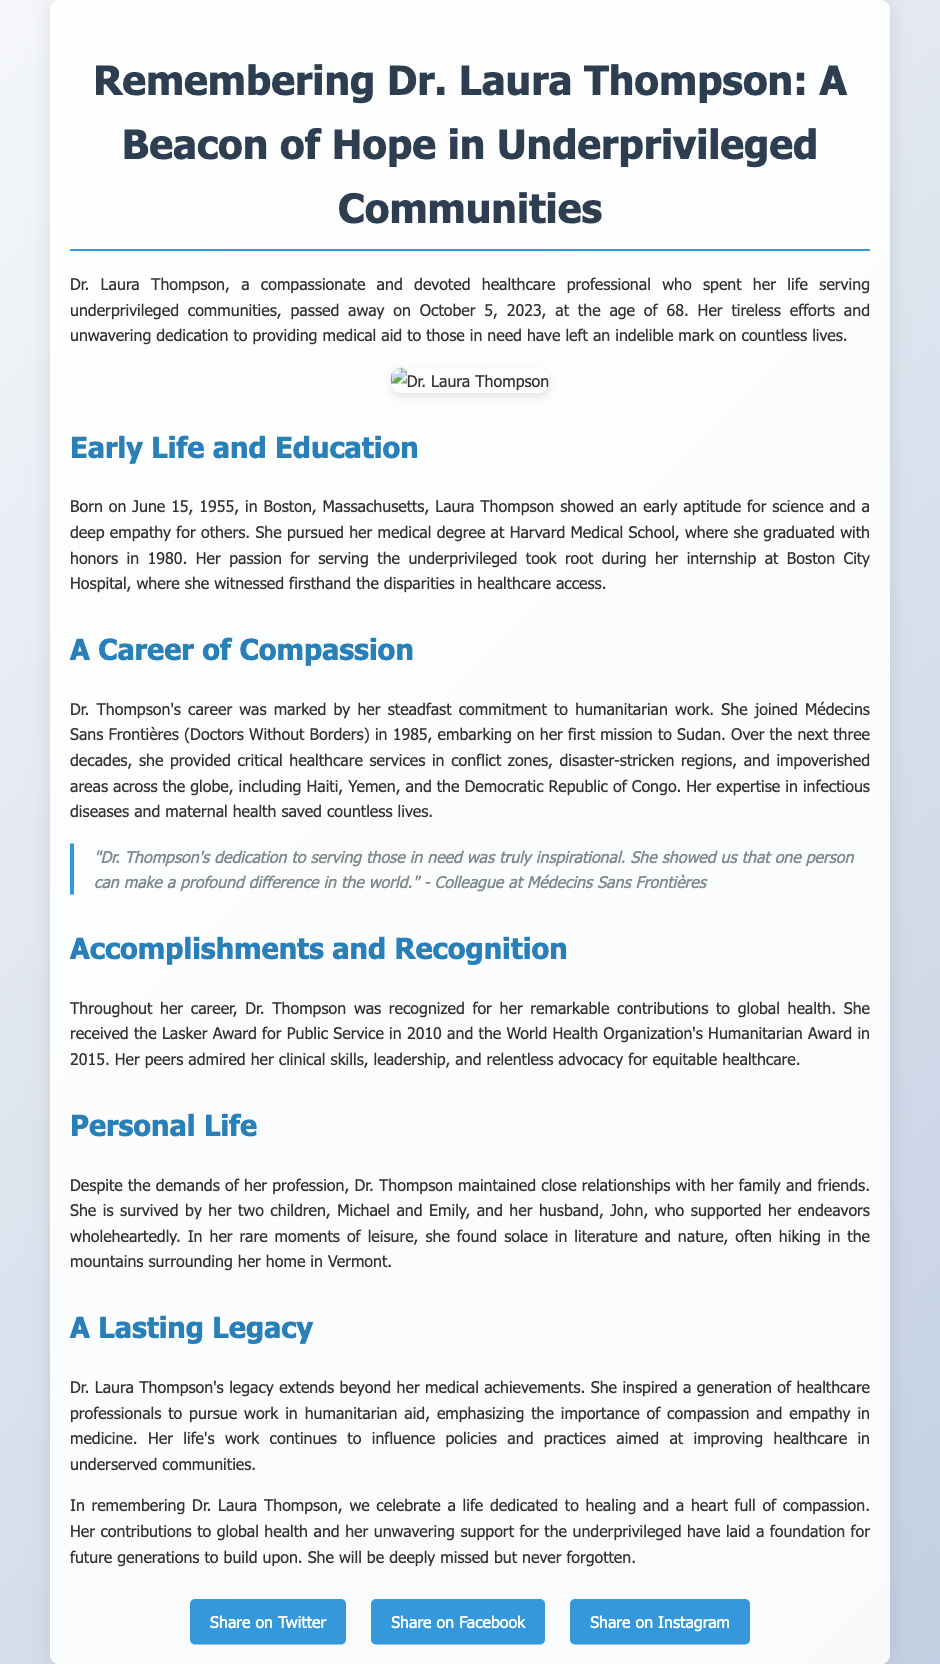What was Dr. Laura Thompson's profession? The document describes her as a healthcare professional who devoted her life to serving underprivileged communities.
Answer: healthcare professional When did Dr. Laura Thompson pass away? The obituary states that she passed away on October 5, 2023.
Answer: October 5, 2023 What award did Dr. Thompson receive in 2010? The document mentions that she received the Lasker Award for Public Service in 2010.
Answer: Lasker Award for Public Service In which country did Dr. Thompson embark on her first mission with Médecins Sans Frontières? The document states that her first mission was to Sudan.
Answer: Sudan What year was Dr. Laura Thompson born? The document states she was born on June 15, 1955.
Answer: 1955 How many children did Dr. Thompson have? The personal life section notes that she is survived by her two children.
Answer: two What major theme does Dr. Thompson’s legacy represent in global health? The document emphasizes her legacy of inspiring healthcare professionals to pursue humanitarian aid through compassion and empathy.
Answer: compassion and empathy What university did Dr. Thompson attend for her medical degree? The document reveals that she pursued her medical degree at Harvard Medical School.
Answer: Harvard Medical School What did Dr. Thompson often do in her leisure time? The document mentions that she found solace in literature and nature, often hiking in the mountains.
Answer: hiking 